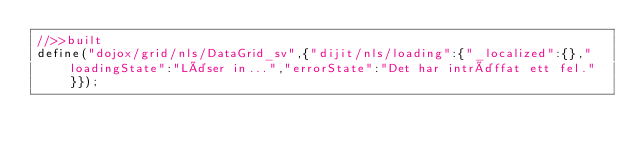Convert code to text. <code><loc_0><loc_0><loc_500><loc_500><_JavaScript_>//>>built
define("dojox/grid/nls/DataGrid_sv",{"dijit/nls/loading":{"_localized":{},"loadingState":"Läser in...","errorState":"Det har inträffat ett fel."}});
</code> 